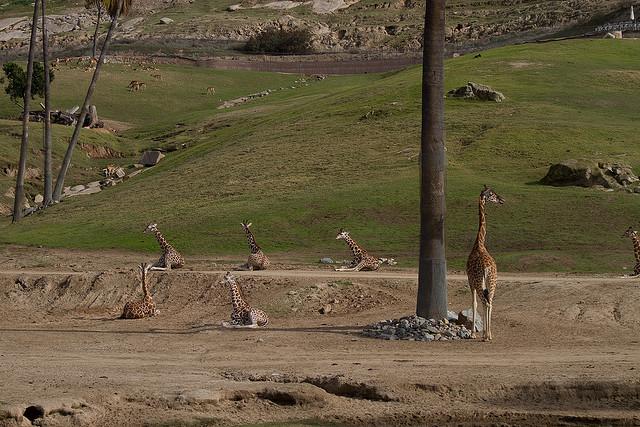Is there more dirt than grass?
Keep it brief. No. What is the ratio of giraffes in the sun to giraffes in the shade?
Short answer required. 6:0. What are these animals  called?
Answer briefly. Giraffe. What is the giraffe in front about to do?
Short answer required. Walk. Is it day time?
Write a very short answer. Yes. How many giraffes are in the picture?
Concise answer only. 6. How many giraffes are in this photo?
Quick response, please. 6. 